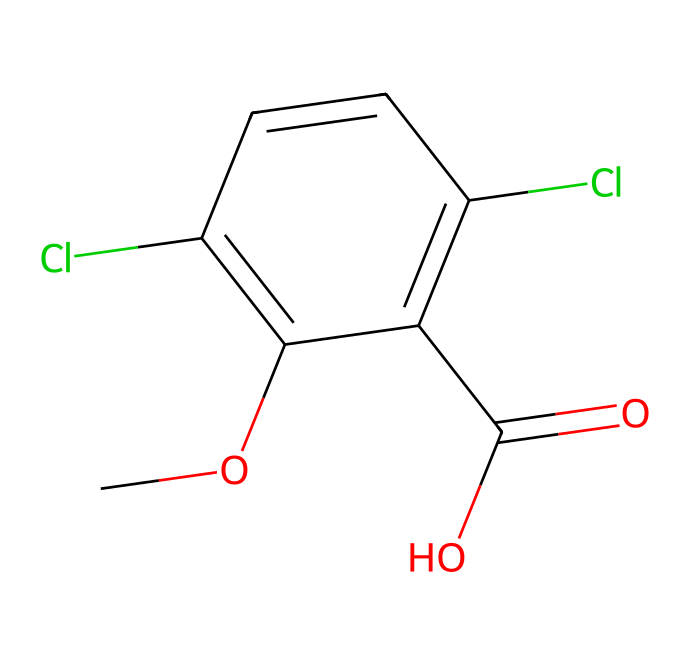What is the molecular formula of this herbicide? To determine the molecular formula, count all the atoms represented in the SMILES structure: there are 10 carbons (C), 8 hydrogens (H), 2 chlorines (Cl), and 2 oxygens (O). Therefore, the molecular formula can be constructed as C10H8Cl2O2.
Answer: C10H8Cl2O2 How many chlorine atoms are present in dicamba? By examining the SMILES representation, chlorine is denoted by the 'Cl' symbols. There are two occurrences of 'Cl', indicating the presence of two chlorine atoms.
Answer: 2 What type of function group can be identified in dicamba? The chemical structure contains a carboxylic acid functional group represented by the presence of the 'C(=O)O' segment. This indicates that it has the -COOH group characteristic of carboxylic acids.
Answer: carboxylic acid Which part of the compound is primarily responsible for its herbicidal activity? The presence of the carboxylic acid group (C(=O)O) is typically associated with the herbicidal activity in such compounds. This group can interact with biochemical pathways in plants, leading to herbicidal effects.
Answer: carboxylic acid What is the significance of the chlorinated aromatic ring in dicamba? The chlorinated aromatic ring increases the lipophilicity of the molecule, contributing to its ability to penetrate plant tissues effectively, which enhances its activity as a herbicide.
Answer: increases lipophilicity How does the structure of dicamba suggest its solubility in water? The presence of the carboxylic acid functional group (C(=O)O) suggests that dicamba can form hydrogen bonds with water molecules, enhancing its solubility in water compared to nonpolar compounds.
Answer: enhances solubility What is the total number of rings present in this chemical structure? By analyzing the SMILES, we observe that the 'c' characters denote aromatic carbons, which imply the presence of one ring structure in the dicamba molecule.
Answer: 1 